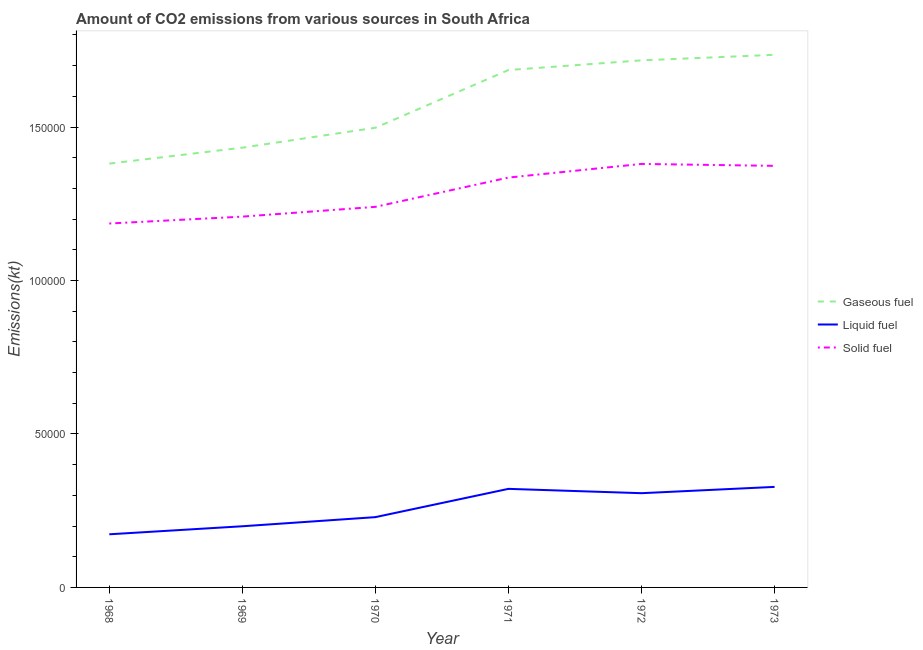What is the amount of co2 emissions from gaseous fuel in 1972?
Ensure brevity in your answer.  1.72e+05. Across all years, what is the maximum amount of co2 emissions from gaseous fuel?
Ensure brevity in your answer.  1.74e+05. Across all years, what is the minimum amount of co2 emissions from solid fuel?
Offer a very short reply. 1.19e+05. In which year was the amount of co2 emissions from gaseous fuel maximum?
Your response must be concise. 1973. In which year was the amount of co2 emissions from solid fuel minimum?
Offer a very short reply. 1968. What is the total amount of co2 emissions from liquid fuel in the graph?
Your answer should be compact. 1.56e+05. What is the difference between the amount of co2 emissions from liquid fuel in 1968 and that in 1973?
Offer a very short reply. -1.54e+04. What is the difference between the amount of co2 emissions from solid fuel in 1972 and the amount of co2 emissions from liquid fuel in 1970?
Your answer should be very brief. 1.15e+05. What is the average amount of co2 emissions from solid fuel per year?
Offer a terse response. 1.29e+05. In the year 1971, what is the difference between the amount of co2 emissions from gaseous fuel and amount of co2 emissions from solid fuel?
Offer a terse response. 3.50e+04. What is the ratio of the amount of co2 emissions from gaseous fuel in 1968 to that in 1969?
Offer a terse response. 0.96. Is the amount of co2 emissions from liquid fuel in 1968 less than that in 1970?
Make the answer very short. Yes. Is the difference between the amount of co2 emissions from gaseous fuel in 1969 and 1972 greater than the difference between the amount of co2 emissions from solid fuel in 1969 and 1972?
Ensure brevity in your answer.  No. What is the difference between the highest and the second highest amount of co2 emissions from liquid fuel?
Ensure brevity in your answer.  641.73. What is the difference between the highest and the lowest amount of co2 emissions from liquid fuel?
Give a very brief answer. 1.54e+04. Is the sum of the amount of co2 emissions from liquid fuel in 1969 and 1972 greater than the maximum amount of co2 emissions from solid fuel across all years?
Provide a short and direct response. No. Is it the case that in every year, the sum of the amount of co2 emissions from gaseous fuel and amount of co2 emissions from liquid fuel is greater than the amount of co2 emissions from solid fuel?
Keep it short and to the point. Yes. Does the amount of co2 emissions from solid fuel monotonically increase over the years?
Provide a succinct answer. No. How many years are there in the graph?
Ensure brevity in your answer.  6. What is the difference between two consecutive major ticks on the Y-axis?
Keep it short and to the point. 5.00e+04. Does the graph contain grids?
Provide a succinct answer. No. How many legend labels are there?
Provide a short and direct response. 3. How are the legend labels stacked?
Your answer should be very brief. Vertical. What is the title of the graph?
Offer a terse response. Amount of CO2 emissions from various sources in South Africa. Does "Travel services" appear as one of the legend labels in the graph?
Give a very brief answer. No. What is the label or title of the Y-axis?
Your answer should be compact. Emissions(kt). What is the Emissions(kt) in Gaseous fuel in 1968?
Make the answer very short. 1.38e+05. What is the Emissions(kt) of Liquid fuel in 1968?
Offer a terse response. 1.73e+04. What is the Emissions(kt) in Solid fuel in 1968?
Offer a very short reply. 1.19e+05. What is the Emissions(kt) in Gaseous fuel in 1969?
Give a very brief answer. 1.43e+05. What is the Emissions(kt) of Liquid fuel in 1969?
Make the answer very short. 1.99e+04. What is the Emissions(kt) in Solid fuel in 1969?
Offer a very short reply. 1.21e+05. What is the Emissions(kt) of Gaseous fuel in 1970?
Your answer should be very brief. 1.50e+05. What is the Emissions(kt) in Liquid fuel in 1970?
Make the answer very short. 2.29e+04. What is the Emissions(kt) of Solid fuel in 1970?
Ensure brevity in your answer.  1.24e+05. What is the Emissions(kt) in Gaseous fuel in 1971?
Offer a very short reply. 1.69e+05. What is the Emissions(kt) of Liquid fuel in 1971?
Make the answer very short. 3.21e+04. What is the Emissions(kt) of Solid fuel in 1971?
Keep it short and to the point. 1.34e+05. What is the Emissions(kt) of Gaseous fuel in 1972?
Provide a short and direct response. 1.72e+05. What is the Emissions(kt) in Liquid fuel in 1972?
Make the answer very short. 3.07e+04. What is the Emissions(kt) in Solid fuel in 1972?
Your response must be concise. 1.38e+05. What is the Emissions(kt) of Gaseous fuel in 1973?
Give a very brief answer. 1.74e+05. What is the Emissions(kt) of Liquid fuel in 1973?
Provide a short and direct response. 3.28e+04. What is the Emissions(kt) in Solid fuel in 1973?
Give a very brief answer. 1.37e+05. Across all years, what is the maximum Emissions(kt) of Gaseous fuel?
Provide a succinct answer. 1.74e+05. Across all years, what is the maximum Emissions(kt) of Liquid fuel?
Provide a short and direct response. 3.28e+04. Across all years, what is the maximum Emissions(kt) of Solid fuel?
Your answer should be very brief. 1.38e+05. Across all years, what is the minimum Emissions(kt) in Gaseous fuel?
Your answer should be very brief. 1.38e+05. Across all years, what is the minimum Emissions(kt) of Liquid fuel?
Your answer should be very brief. 1.73e+04. Across all years, what is the minimum Emissions(kt) in Solid fuel?
Make the answer very short. 1.19e+05. What is the total Emissions(kt) of Gaseous fuel in the graph?
Your answer should be very brief. 9.45e+05. What is the total Emissions(kt) of Liquid fuel in the graph?
Ensure brevity in your answer.  1.56e+05. What is the total Emissions(kt) in Solid fuel in the graph?
Offer a terse response. 7.72e+05. What is the difference between the Emissions(kt) in Gaseous fuel in 1968 and that in 1969?
Your answer should be compact. -5196.14. What is the difference between the Emissions(kt) of Liquid fuel in 1968 and that in 1969?
Ensure brevity in your answer.  -2614.57. What is the difference between the Emissions(kt) in Solid fuel in 1968 and that in 1969?
Your answer should be very brief. -2240.54. What is the difference between the Emissions(kt) of Gaseous fuel in 1968 and that in 1970?
Your response must be concise. -1.17e+04. What is the difference between the Emissions(kt) in Liquid fuel in 1968 and that in 1970?
Offer a very short reply. -5588.51. What is the difference between the Emissions(kt) of Solid fuel in 1968 and that in 1970?
Give a very brief answer. -5427.16. What is the difference between the Emissions(kt) in Gaseous fuel in 1968 and that in 1971?
Your answer should be very brief. -3.05e+04. What is the difference between the Emissions(kt) of Liquid fuel in 1968 and that in 1971?
Give a very brief answer. -1.48e+04. What is the difference between the Emissions(kt) of Solid fuel in 1968 and that in 1971?
Provide a short and direct response. -1.50e+04. What is the difference between the Emissions(kt) in Gaseous fuel in 1968 and that in 1972?
Provide a short and direct response. -3.36e+04. What is the difference between the Emissions(kt) in Liquid fuel in 1968 and that in 1972?
Give a very brief answer. -1.34e+04. What is the difference between the Emissions(kt) in Solid fuel in 1968 and that in 1972?
Make the answer very short. -1.94e+04. What is the difference between the Emissions(kt) of Gaseous fuel in 1968 and that in 1973?
Your answer should be very brief. -3.54e+04. What is the difference between the Emissions(kt) of Liquid fuel in 1968 and that in 1973?
Ensure brevity in your answer.  -1.54e+04. What is the difference between the Emissions(kt) in Solid fuel in 1968 and that in 1973?
Keep it short and to the point. -1.88e+04. What is the difference between the Emissions(kt) of Gaseous fuel in 1969 and that in 1970?
Ensure brevity in your answer.  -6483.26. What is the difference between the Emissions(kt) in Liquid fuel in 1969 and that in 1970?
Offer a terse response. -2973.94. What is the difference between the Emissions(kt) of Solid fuel in 1969 and that in 1970?
Provide a short and direct response. -3186.62. What is the difference between the Emissions(kt) of Gaseous fuel in 1969 and that in 1971?
Make the answer very short. -2.53e+04. What is the difference between the Emissions(kt) of Liquid fuel in 1969 and that in 1971?
Offer a terse response. -1.22e+04. What is the difference between the Emissions(kt) of Solid fuel in 1969 and that in 1971?
Make the answer very short. -1.27e+04. What is the difference between the Emissions(kt) of Gaseous fuel in 1969 and that in 1972?
Offer a very short reply. -2.84e+04. What is the difference between the Emissions(kt) of Liquid fuel in 1969 and that in 1972?
Your answer should be very brief. -1.08e+04. What is the difference between the Emissions(kt) of Solid fuel in 1969 and that in 1972?
Ensure brevity in your answer.  -1.72e+04. What is the difference between the Emissions(kt) in Gaseous fuel in 1969 and that in 1973?
Ensure brevity in your answer.  -3.03e+04. What is the difference between the Emissions(kt) in Liquid fuel in 1969 and that in 1973?
Offer a very short reply. -1.28e+04. What is the difference between the Emissions(kt) in Solid fuel in 1969 and that in 1973?
Offer a very short reply. -1.65e+04. What is the difference between the Emissions(kt) in Gaseous fuel in 1970 and that in 1971?
Give a very brief answer. -1.88e+04. What is the difference between the Emissions(kt) of Liquid fuel in 1970 and that in 1971?
Your answer should be compact. -9215.17. What is the difference between the Emissions(kt) in Solid fuel in 1970 and that in 1971?
Keep it short and to the point. -9537.87. What is the difference between the Emissions(kt) in Gaseous fuel in 1970 and that in 1972?
Your answer should be compact. -2.20e+04. What is the difference between the Emissions(kt) of Liquid fuel in 1970 and that in 1972?
Provide a short and direct response. -7803.38. What is the difference between the Emissions(kt) of Solid fuel in 1970 and that in 1972?
Make the answer very short. -1.40e+04. What is the difference between the Emissions(kt) in Gaseous fuel in 1970 and that in 1973?
Make the answer very short. -2.38e+04. What is the difference between the Emissions(kt) in Liquid fuel in 1970 and that in 1973?
Offer a terse response. -9856.9. What is the difference between the Emissions(kt) of Solid fuel in 1970 and that in 1973?
Your response must be concise. -1.34e+04. What is the difference between the Emissions(kt) in Gaseous fuel in 1971 and that in 1972?
Your answer should be compact. -3157.29. What is the difference between the Emissions(kt) in Liquid fuel in 1971 and that in 1972?
Your answer should be compact. 1411.8. What is the difference between the Emissions(kt) in Solid fuel in 1971 and that in 1972?
Provide a short and direct response. -4444.4. What is the difference between the Emissions(kt) of Gaseous fuel in 1971 and that in 1973?
Make the answer very short. -4965.12. What is the difference between the Emissions(kt) of Liquid fuel in 1971 and that in 1973?
Your response must be concise. -641.73. What is the difference between the Emissions(kt) in Solid fuel in 1971 and that in 1973?
Your answer should be compact. -3817.35. What is the difference between the Emissions(kt) in Gaseous fuel in 1972 and that in 1973?
Your answer should be compact. -1807.83. What is the difference between the Emissions(kt) of Liquid fuel in 1972 and that in 1973?
Your response must be concise. -2053.52. What is the difference between the Emissions(kt) of Solid fuel in 1972 and that in 1973?
Ensure brevity in your answer.  627.06. What is the difference between the Emissions(kt) of Gaseous fuel in 1968 and the Emissions(kt) of Liquid fuel in 1969?
Keep it short and to the point. 1.18e+05. What is the difference between the Emissions(kt) of Gaseous fuel in 1968 and the Emissions(kt) of Solid fuel in 1969?
Make the answer very short. 1.73e+04. What is the difference between the Emissions(kt) of Liquid fuel in 1968 and the Emissions(kt) of Solid fuel in 1969?
Provide a short and direct response. -1.03e+05. What is the difference between the Emissions(kt) in Gaseous fuel in 1968 and the Emissions(kt) in Liquid fuel in 1970?
Make the answer very short. 1.15e+05. What is the difference between the Emissions(kt) in Gaseous fuel in 1968 and the Emissions(kt) in Solid fuel in 1970?
Provide a short and direct response. 1.41e+04. What is the difference between the Emissions(kt) of Liquid fuel in 1968 and the Emissions(kt) of Solid fuel in 1970?
Keep it short and to the point. -1.07e+05. What is the difference between the Emissions(kt) of Gaseous fuel in 1968 and the Emissions(kt) of Liquid fuel in 1971?
Provide a succinct answer. 1.06e+05. What is the difference between the Emissions(kt) in Gaseous fuel in 1968 and the Emissions(kt) in Solid fuel in 1971?
Provide a succinct answer. 4550.75. What is the difference between the Emissions(kt) in Liquid fuel in 1968 and the Emissions(kt) in Solid fuel in 1971?
Offer a terse response. -1.16e+05. What is the difference between the Emissions(kt) in Gaseous fuel in 1968 and the Emissions(kt) in Liquid fuel in 1972?
Keep it short and to the point. 1.07e+05. What is the difference between the Emissions(kt) in Gaseous fuel in 1968 and the Emissions(kt) in Solid fuel in 1972?
Your answer should be compact. 106.34. What is the difference between the Emissions(kt) in Liquid fuel in 1968 and the Emissions(kt) in Solid fuel in 1972?
Your answer should be compact. -1.21e+05. What is the difference between the Emissions(kt) in Gaseous fuel in 1968 and the Emissions(kt) in Liquid fuel in 1973?
Your answer should be very brief. 1.05e+05. What is the difference between the Emissions(kt) of Gaseous fuel in 1968 and the Emissions(kt) of Solid fuel in 1973?
Make the answer very short. 733.4. What is the difference between the Emissions(kt) of Liquid fuel in 1968 and the Emissions(kt) of Solid fuel in 1973?
Your answer should be compact. -1.20e+05. What is the difference between the Emissions(kt) in Gaseous fuel in 1969 and the Emissions(kt) in Liquid fuel in 1970?
Give a very brief answer. 1.20e+05. What is the difference between the Emissions(kt) of Gaseous fuel in 1969 and the Emissions(kt) of Solid fuel in 1970?
Your response must be concise. 1.93e+04. What is the difference between the Emissions(kt) in Liquid fuel in 1969 and the Emissions(kt) in Solid fuel in 1970?
Offer a very short reply. -1.04e+05. What is the difference between the Emissions(kt) in Gaseous fuel in 1969 and the Emissions(kt) in Liquid fuel in 1971?
Your answer should be very brief. 1.11e+05. What is the difference between the Emissions(kt) in Gaseous fuel in 1969 and the Emissions(kt) in Solid fuel in 1971?
Offer a very short reply. 9746.89. What is the difference between the Emissions(kt) of Liquid fuel in 1969 and the Emissions(kt) of Solid fuel in 1971?
Offer a very short reply. -1.14e+05. What is the difference between the Emissions(kt) in Gaseous fuel in 1969 and the Emissions(kt) in Liquid fuel in 1972?
Give a very brief answer. 1.13e+05. What is the difference between the Emissions(kt) of Gaseous fuel in 1969 and the Emissions(kt) of Solid fuel in 1972?
Your answer should be very brief. 5302.48. What is the difference between the Emissions(kt) in Liquid fuel in 1969 and the Emissions(kt) in Solid fuel in 1972?
Ensure brevity in your answer.  -1.18e+05. What is the difference between the Emissions(kt) of Gaseous fuel in 1969 and the Emissions(kt) of Liquid fuel in 1973?
Ensure brevity in your answer.  1.11e+05. What is the difference between the Emissions(kt) of Gaseous fuel in 1969 and the Emissions(kt) of Solid fuel in 1973?
Your answer should be compact. 5929.54. What is the difference between the Emissions(kt) of Liquid fuel in 1969 and the Emissions(kt) of Solid fuel in 1973?
Your answer should be very brief. -1.17e+05. What is the difference between the Emissions(kt) of Gaseous fuel in 1970 and the Emissions(kt) of Liquid fuel in 1971?
Provide a short and direct response. 1.18e+05. What is the difference between the Emissions(kt) in Gaseous fuel in 1970 and the Emissions(kt) in Solid fuel in 1971?
Ensure brevity in your answer.  1.62e+04. What is the difference between the Emissions(kt) of Liquid fuel in 1970 and the Emissions(kt) of Solid fuel in 1971?
Your response must be concise. -1.11e+05. What is the difference between the Emissions(kt) of Gaseous fuel in 1970 and the Emissions(kt) of Liquid fuel in 1972?
Keep it short and to the point. 1.19e+05. What is the difference between the Emissions(kt) in Gaseous fuel in 1970 and the Emissions(kt) in Solid fuel in 1972?
Ensure brevity in your answer.  1.18e+04. What is the difference between the Emissions(kt) in Liquid fuel in 1970 and the Emissions(kt) in Solid fuel in 1972?
Give a very brief answer. -1.15e+05. What is the difference between the Emissions(kt) of Gaseous fuel in 1970 and the Emissions(kt) of Liquid fuel in 1973?
Offer a terse response. 1.17e+05. What is the difference between the Emissions(kt) in Gaseous fuel in 1970 and the Emissions(kt) in Solid fuel in 1973?
Give a very brief answer. 1.24e+04. What is the difference between the Emissions(kt) of Liquid fuel in 1970 and the Emissions(kt) of Solid fuel in 1973?
Provide a short and direct response. -1.14e+05. What is the difference between the Emissions(kt) of Gaseous fuel in 1971 and the Emissions(kt) of Liquid fuel in 1972?
Offer a very short reply. 1.38e+05. What is the difference between the Emissions(kt) of Gaseous fuel in 1971 and the Emissions(kt) of Solid fuel in 1972?
Make the answer very short. 3.06e+04. What is the difference between the Emissions(kt) of Liquid fuel in 1971 and the Emissions(kt) of Solid fuel in 1972?
Your answer should be very brief. -1.06e+05. What is the difference between the Emissions(kt) in Gaseous fuel in 1971 and the Emissions(kt) in Liquid fuel in 1973?
Your answer should be very brief. 1.36e+05. What is the difference between the Emissions(kt) in Gaseous fuel in 1971 and the Emissions(kt) in Solid fuel in 1973?
Your response must be concise. 3.12e+04. What is the difference between the Emissions(kt) of Liquid fuel in 1971 and the Emissions(kt) of Solid fuel in 1973?
Offer a very short reply. -1.05e+05. What is the difference between the Emissions(kt) of Gaseous fuel in 1972 and the Emissions(kt) of Liquid fuel in 1973?
Give a very brief answer. 1.39e+05. What is the difference between the Emissions(kt) of Gaseous fuel in 1972 and the Emissions(kt) of Solid fuel in 1973?
Keep it short and to the point. 3.44e+04. What is the difference between the Emissions(kt) of Liquid fuel in 1972 and the Emissions(kt) of Solid fuel in 1973?
Provide a short and direct response. -1.07e+05. What is the average Emissions(kt) of Gaseous fuel per year?
Give a very brief answer. 1.57e+05. What is the average Emissions(kt) in Liquid fuel per year?
Ensure brevity in your answer.  2.60e+04. What is the average Emissions(kt) of Solid fuel per year?
Make the answer very short. 1.29e+05. In the year 1968, what is the difference between the Emissions(kt) of Gaseous fuel and Emissions(kt) of Liquid fuel?
Make the answer very short. 1.21e+05. In the year 1968, what is the difference between the Emissions(kt) in Gaseous fuel and Emissions(kt) in Solid fuel?
Ensure brevity in your answer.  1.95e+04. In the year 1968, what is the difference between the Emissions(kt) in Liquid fuel and Emissions(kt) in Solid fuel?
Provide a short and direct response. -1.01e+05. In the year 1969, what is the difference between the Emissions(kt) of Gaseous fuel and Emissions(kt) of Liquid fuel?
Your answer should be very brief. 1.23e+05. In the year 1969, what is the difference between the Emissions(kt) in Gaseous fuel and Emissions(kt) in Solid fuel?
Make the answer very short. 2.25e+04. In the year 1969, what is the difference between the Emissions(kt) in Liquid fuel and Emissions(kt) in Solid fuel?
Make the answer very short. -1.01e+05. In the year 1970, what is the difference between the Emissions(kt) of Gaseous fuel and Emissions(kt) of Liquid fuel?
Ensure brevity in your answer.  1.27e+05. In the year 1970, what is the difference between the Emissions(kt) of Gaseous fuel and Emissions(kt) of Solid fuel?
Give a very brief answer. 2.58e+04. In the year 1970, what is the difference between the Emissions(kt) of Liquid fuel and Emissions(kt) of Solid fuel?
Your answer should be very brief. -1.01e+05. In the year 1971, what is the difference between the Emissions(kt) of Gaseous fuel and Emissions(kt) of Liquid fuel?
Provide a short and direct response. 1.36e+05. In the year 1971, what is the difference between the Emissions(kt) of Gaseous fuel and Emissions(kt) of Solid fuel?
Make the answer very short. 3.50e+04. In the year 1971, what is the difference between the Emissions(kt) in Liquid fuel and Emissions(kt) in Solid fuel?
Your answer should be very brief. -1.01e+05. In the year 1972, what is the difference between the Emissions(kt) of Gaseous fuel and Emissions(kt) of Liquid fuel?
Give a very brief answer. 1.41e+05. In the year 1972, what is the difference between the Emissions(kt) in Gaseous fuel and Emissions(kt) in Solid fuel?
Provide a succinct answer. 3.37e+04. In the year 1972, what is the difference between the Emissions(kt) in Liquid fuel and Emissions(kt) in Solid fuel?
Offer a very short reply. -1.07e+05. In the year 1973, what is the difference between the Emissions(kt) in Gaseous fuel and Emissions(kt) in Liquid fuel?
Your answer should be compact. 1.41e+05. In the year 1973, what is the difference between the Emissions(kt) of Gaseous fuel and Emissions(kt) of Solid fuel?
Keep it short and to the point. 3.62e+04. In the year 1973, what is the difference between the Emissions(kt) in Liquid fuel and Emissions(kt) in Solid fuel?
Provide a short and direct response. -1.05e+05. What is the ratio of the Emissions(kt) of Gaseous fuel in 1968 to that in 1969?
Provide a succinct answer. 0.96. What is the ratio of the Emissions(kt) of Liquid fuel in 1968 to that in 1969?
Your response must be concise. 0.87. What is the ratio of the Emissions(kt) of Solid fuel in 1968 to that in 1969?
Keep it short and to the point. 0.98. What is the ratio of the Emissions(kt) of Gaseous fuel in 1968 to that in 1970?
Your answer should be very brief. 0.92. What is the ratio of the Emissions(kt) in Liquid fuel in 1968 to that in 1970?
Ensure brevity in your answer.  0.76. What is the ratio of the Emissions(kt) of Solid fuel in 1968 to that in 1970?
Make the answer very short. 0.96. What is the ratio of the Emissions(kt) of Gaseous fuel in 1968 to that in 1971?
Ensure brevity in your answer.  0.82. What is the ratio of the Emissions(kt) in Liquid fuel in 1968 to that in 1971?
Provide a succinct answer. 0.54. What is the ratio of the Emissions(kt) in Solid fuel in 1968 to that in 1971?
Provide a short and direct response. 0.89. What is the ratio of the Emissions(kt) of Gaseous fuel in 1968 to that in 1972?
Provide a short and direct response. 0.8. What is the ratio of the Emissions(kt) in Liquid fuel in 1968 to that in 1972?
Your answer should be very brief. 0.56. What is the ratio of the Emissions(kt) in Solid fuel in 1968 to that in 1972?
Make the answer very short. 0.86. What is the ratio of the Emissions(kt) in Gaseous fuel in 1968 to that in 1973?
Give a very brief answer. 0.8. What is the ratio of the Emissions(kt) in Liquid fuel in 1968 to that in 1973?
Keep it short and to the point. 0.53. What is the ratio of the Emissions(kt) of Solid fuel in 1968 to that in 1973?
Offer a terse response. 0.86. What is the ratio of the Emissions(kt) of Gaseous fuel in 1969 to that in 1970?
Your answer should be very brief. 0.96. What is the ratio of the Emissions(kt) in Liquid fuel in 1969 to that in 1970?
Offer a very short reply. 0.87. What is the ratio of the Emissions(kt) in Solid fuel in 1969 to that in 1970?
Give a very brief answer. 0.97. What is the ratio of the Emissions(kt) in Liquid fuel in 1969 to that in 1971?
Your response must be concise. 0.62. What is the ratio of the Emissions(kt) in Solid fuel in 1969 to that in 1971?
Your answer should be very brief. 0.9. What is the ratio of the Emissions(kt) in Gaseous fuel in 1969 to that in 1972?
Your answer should be very brief. 0.83. What is the ratio of the Emissions(kt) of Liquid fuel in 1969 to that in 1972?
Your response must be concise. 0.65. What is the ratio of the Emissions(kt) of Solid fuel in 1969 to that in 1972?
Your response must be concise. 0.88. What is the ratio of the Emissions(kt) of Gaseous fuel in 1969 to that in 1973?
Offer a very short reply. 0.83. What is the ratio of the Emissions(kt) in Liquid fuel in 1969 to that in 1973?
Offer a terse response. 0.61. What is the ratio of the Emissions(kt) in Solid fuel in 1969 to that in 1973?
Your answer should be very brief. 0.88. What is the ratio of the Emissions(kt) of Gaseous fuel in 1970 to that in 1971?
Make the answer very short. 0.89. What is the ratio of the Emissions(kt) of Liquid fuel in 1970 to that in 1971?
Keep it short and to the point. 0.71. What is the ratio of the Emissions(kt) in Gaseous fuel in 1970 to that in 1972?
Provide a short and direct response. 0.87. What is the ratio of the Emissions(kt) in Liquid fuel in 1970 to that in 1972?
Your answer should be compact. 0.75. What is the ratio of the Emissions(kt) in Solid fuel in 1970 to that in 1972?
Your answer should be compact. 0.9. What is the ratio of the Emissions(kt) in Gaseous fuel in 1970 to that in 1973?
Keep it short and to the point. 0.86. What is the ratio of the Emissions(kt) of Liquid fuel in 1970 to that in 1973?
Provide a short and direct response. 0.7. What is the ratio of the Emissions(kt) in Solid fuel in 1970 to that in 1973?
Your answer should be compact. 0.9. What is the ratio of the Emissions(kt) of Gaseous fuel in 1971 to that in 1972?
Your answer should be very brief. 0.98. What is the ratio of the Emissions(kt) of Liquid fuel in 1971 to that in 1972?
Ensure brevity in your answer.  1.05. What is the ratio of the Emissions(kt) in Solid fuel in 1971 to that in 1972?
Your answer should be compact. 0.97. What is the ratio of the Emissions(kt) in Gaseous fuel in 1971 to that in 1973?
Offer a terse response. 0.97. What is the ratio of the Emissions(kt) in Liquid fuel in 1971 to that in 1973?
Provide a succinct answer. 0.98. What is the ratio of the Emissions(kt) of Solid fuel in 1971 to that in 1973?
Provide a succinct answer. 0.97. What is the ratio of the Emissions(kt) of Liquid fuel in 1972 to that in 1973?
Ensure brevity in your answer.  0.94. What is the difference between the highest and the second highest Emissions(kt) in Gaseous fuel?
Your answer should be compact. 1807.83. What is the difference between the highest and the second highest Emissions(kt) of Liquid fuel?
Provide a short and direct response. 641.73. What is the difference between the highest and the second highest Emissions(kt) of Solid fuel?
Your answer should be compact. 627.06. What is the difference between the highest and the lowest Emissions(kt) in Gaseous fuel?
Offer a very short reply. 3.54e+04. What is the difference between the highest and the lowest Emissions(kt) in Liquid fuel?
Ensure brevity in your answer.  1.54e+04. What is the difference between the highest and the lowest Emissions(kt) in Solid fuel?
Offer a very short reply. 1.94e+04. 